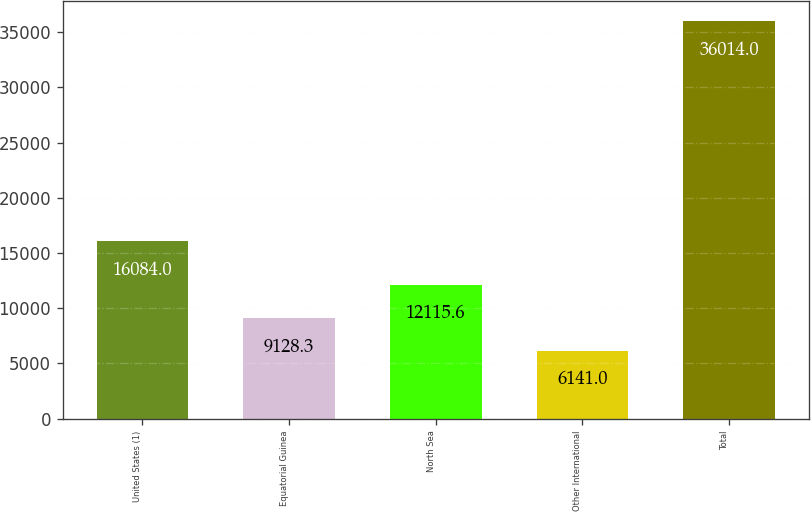Convert chart. <chart><loc_0><loc_0><loc_500><loc_500><bar_chart><fcel>United States (1)<fcel>Equatorial Guinea<fcel>North Sea<fcel>Other International<fcel>Total<nl><fcel>16084<fcel>9128.3<fcel>12115.6<fcel>6141<fcel>36014<nl></chart> 